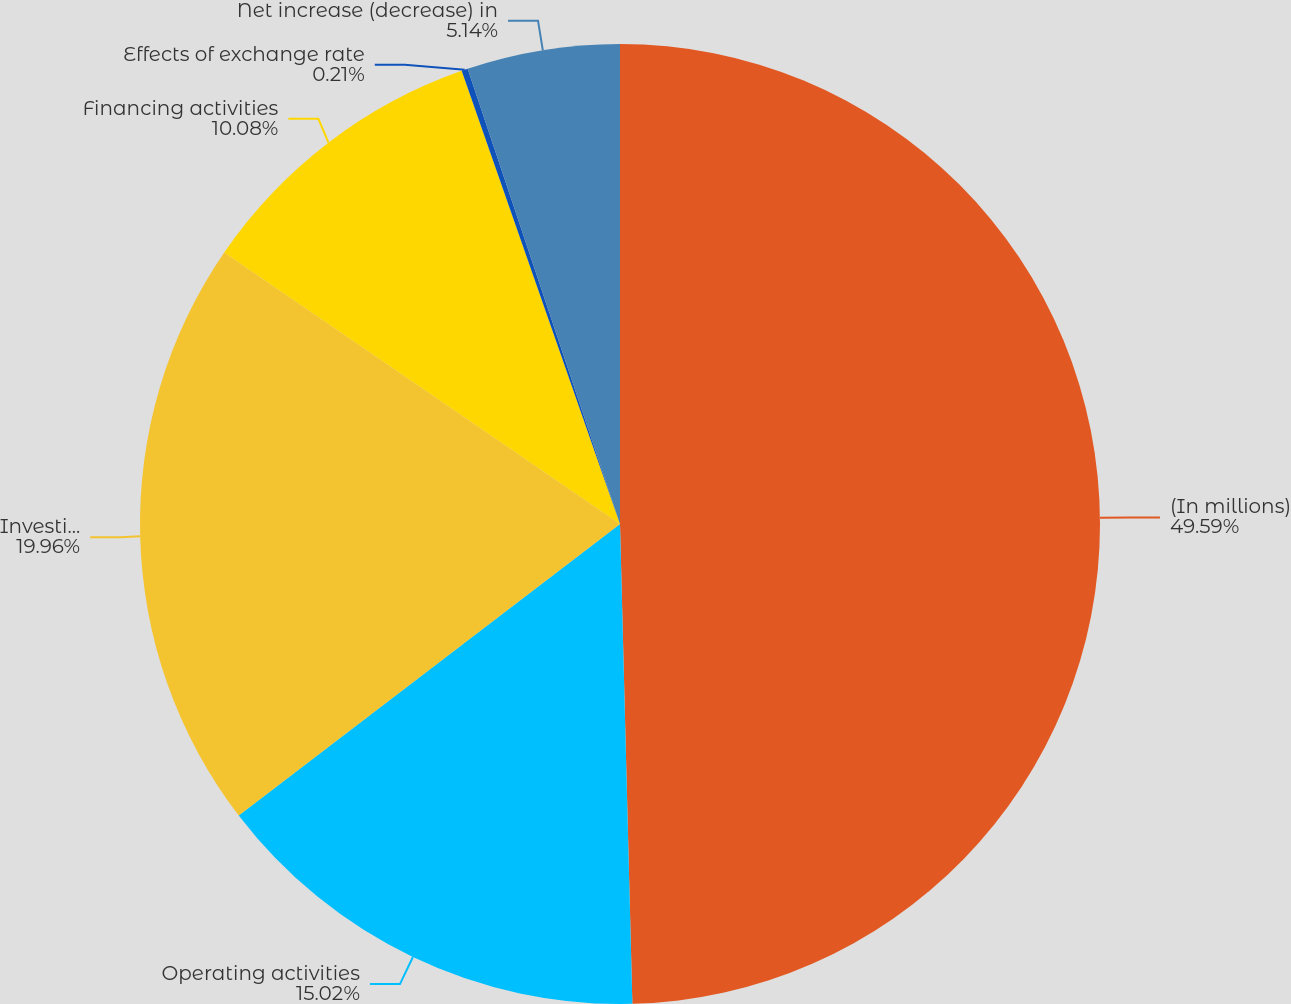<chart> <loc_0><loc_0><loc_500><loc_500><pie_chart><fcel>(In millions)<fcel>Operating activities<fcel>Investing activities<fcel>Financing activities<fcel>Effects of exchange rate<fcel>Net increase (decrease) in<nl><fcel>49.59%<fcel>15.02%<fcel>19.96%<fcel>10.08%<fcel>0.21%<fcel>5.14%<nl></chart> 